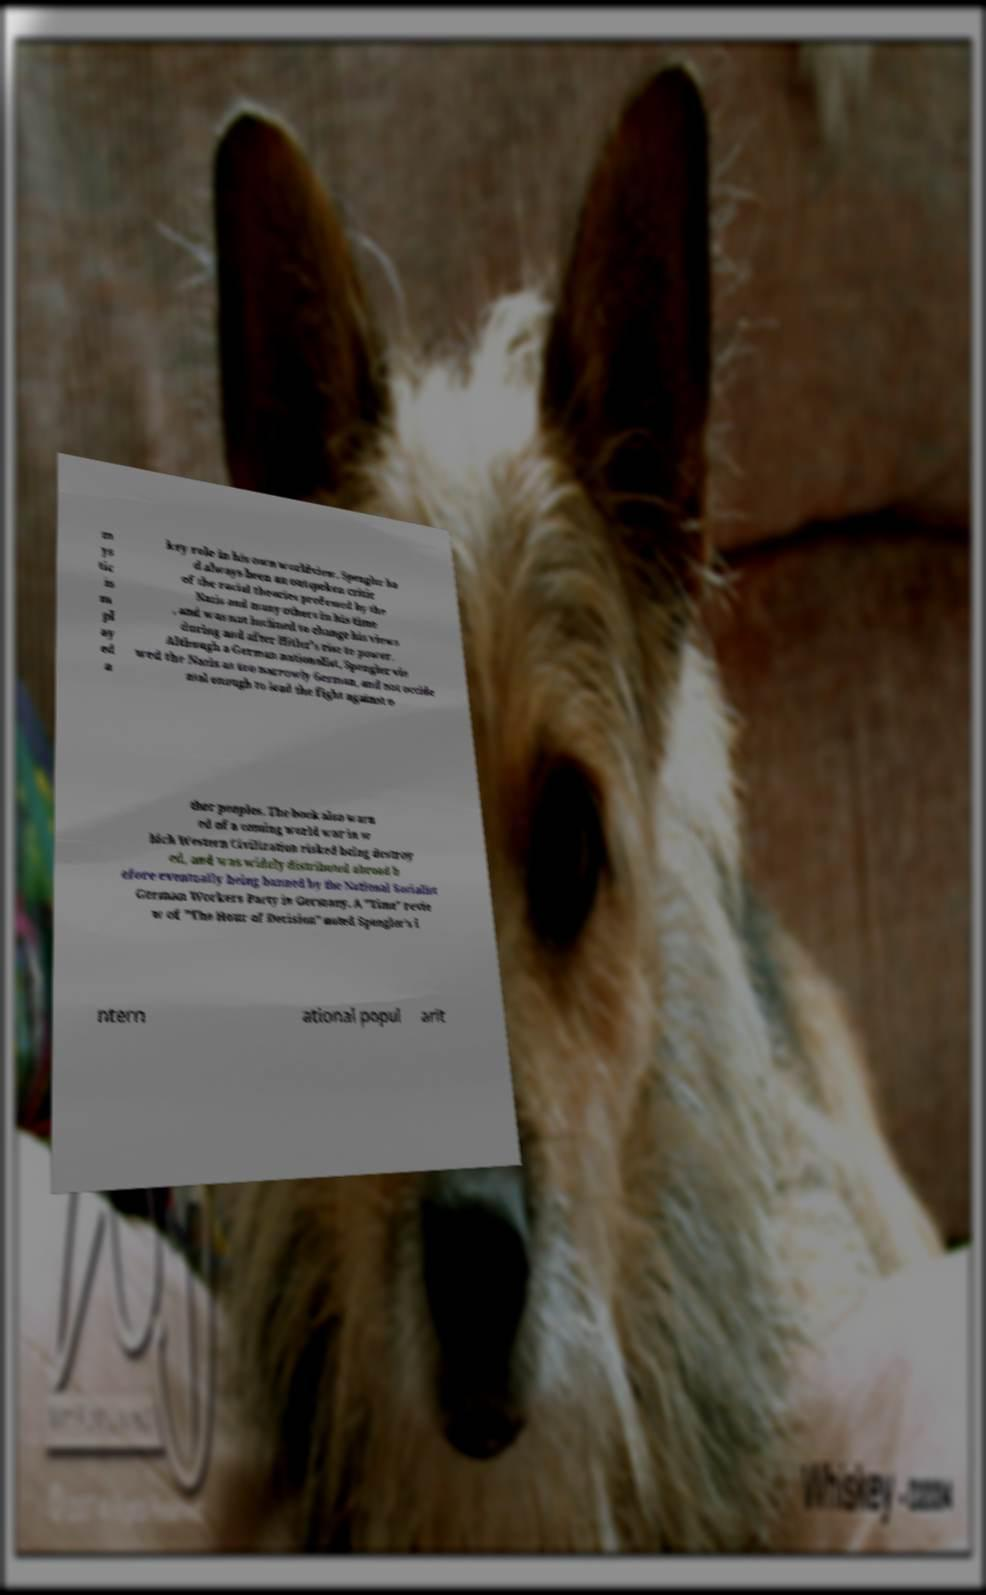Could you extract and type out the text from this image? m ys tic is m pl ay ed a key role in his own worldview, Spengler ha d always been an outspoken critic of the racial theories professed by the Nazis and many others in his time , and was not inclined to change his views during and after Hitler's rise to power. Although a German nationalist, Spengler vie wed the Nazis as too narrowly German, and not occide ntal enough to lead the fight against o ther peoples. The book also warn ed of a coming world war in w hich Western Civilization risked being destroy ed, and was widely distributed abroad b efore eventually being banned by the National Socialist German Workers Party in Germany. A "Time" revie w of "The Hour of Decision" noted Spengler's i ntern ational popul arit 